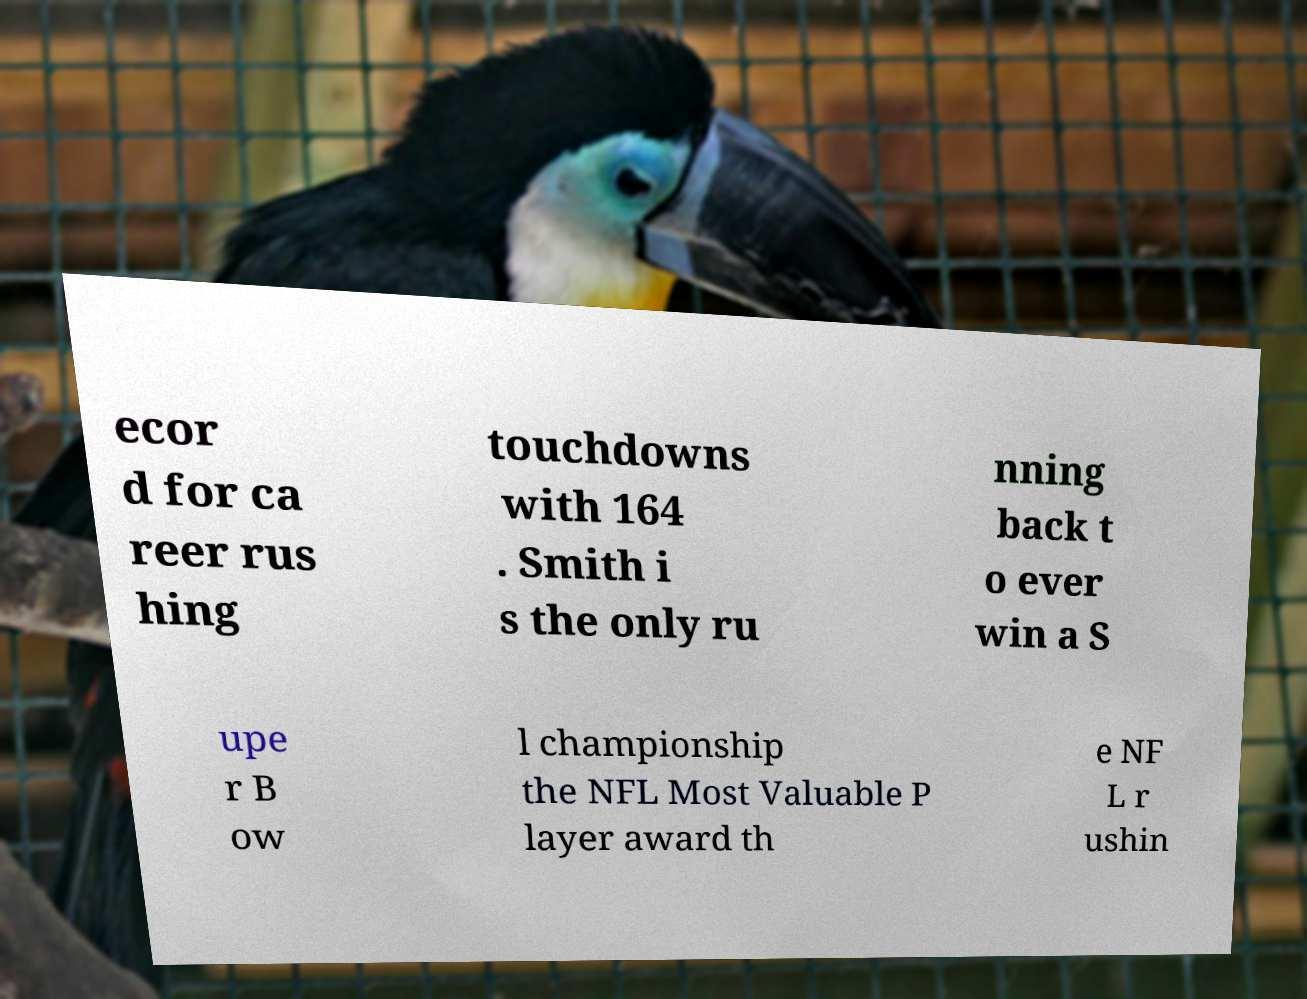There's text embedded in this image that I need extracted. Can you transcribe it verbatim? ecor d for ca reer rus hing touchdowns with 164 . Smith i s the only ru nning back t o ever win a S upe r B ow l championship the NFL Most Valuable P layer award th e NF L r ushin 